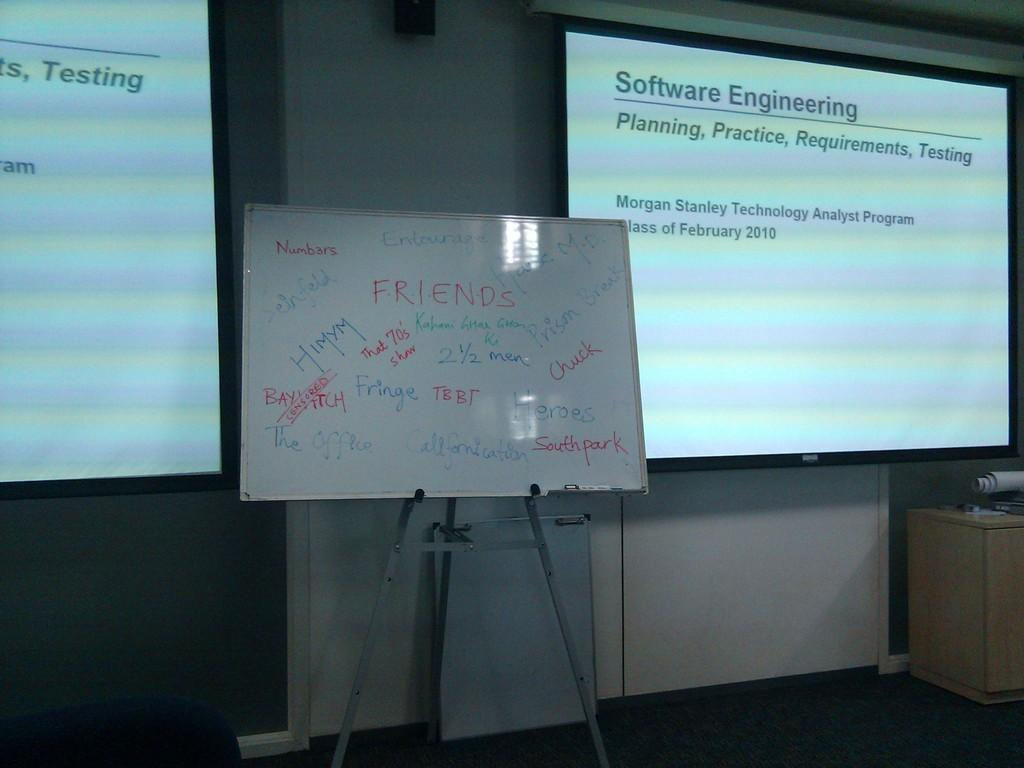<image>
Describe the image concisely. Screen which says Software Engineering on it in the front. 